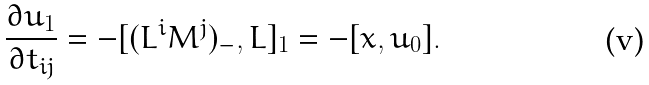<formula> <loc_0><loc_0><loc_500><loc_500>\frac { \partial u _ { 1 } } { \partial t _ { i j } } = - [ ( L ^ { i } M ^ { j } ) _ { - } , L ] _ { 1 } = - [ x , u _ { 0 } ] .</formula> 